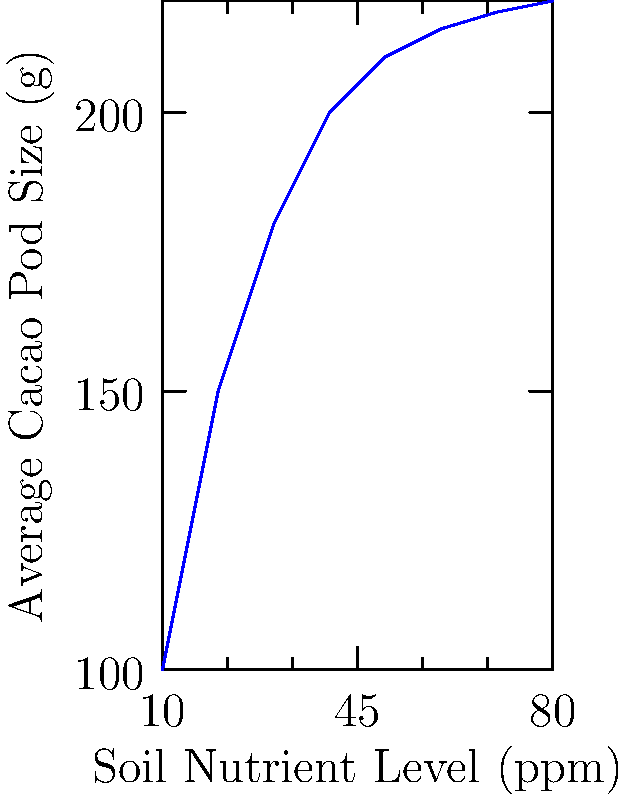Based on the scatter plot showing the relationship between soil nutrient levels and average cacao pod size, what type of function best describes this relationship, and what does this imply about the impact of increasing soil nutrients on pod size? To answer this question, let's analyze the scatter plot step-by-step:

1. Observe the overall trend: As soil nutrient levels increase, the average cacao pod size also increases.

2. Note the shape of the curve: The relationship is not linear. The increase in pod size is more rapid at lower nutrient levels and gradually slows down at higher levels.

3. Identify the function type: This pattern resembles a logarithmic or exponential growth function, specifically a logarithmic function.

4. Interpret the logarithmic relationship:
   a) At lower nutrient levels (10-40 ppm), there's a steep increase in pod size.
   b) As nutrient levels increase further (50-80 ppm), the rate of increase in pod size diminishes.

5. Implication for cacao farming:
   a) Increasing soil nutrients from low to moderate levels (10-40 ppm) has a significant positive impact on pod size.
   b) Beyond a certain point (around 50 ppm), adding more nutrients yields diminishing returns in terms of pod size increase.

6. Practical application: This suggests that there's an optimal range for soil nutrient levels, likely between 40-60 ppm, where the balance between input (nutrients) and output (pod size) is most efficient.

Therefore, the relationship is best described by a logarithmic function, implying that increasing soil nutrients has a strong positive effect on pod size initially, but this effect diminishes at higher nutrient levels.
Answer: Logarithmic; diminishing returns on pod size at higher nutrient levels 